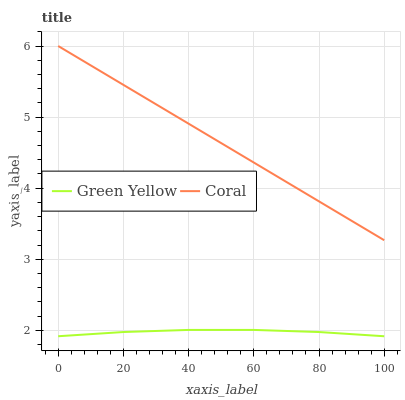Does Green Yellow have the minimum area under the curve?
Answer yes or no. Yes. Does Coral have the maximum area under the curve?
Answer yes or no. Yes. Does Green Yellow have the maximum area under the curve?
Answer yes or no. No. Is Coral the smoothest?
Answer yes or no. Yes. Is Green Yellow the roughest?
Answer yes or no. Yes. Is Green Yellow the smoothest?
Answer yes or no. No. Does Green Yellow have the lowest value?
Answer yes or no. Yes. Does Coral have the highest value?
Answer yes or no. Yes. Does Green Yellow have the highest value?
Answer yes or no. No. Is Green Yellow less than Coral?
Answer yes or no. Yes. Is Coral greater than Green Yellow?
Answer yes or no. Yes. Does Green Yellow intersect Coral?
Answer yes or no. No. 